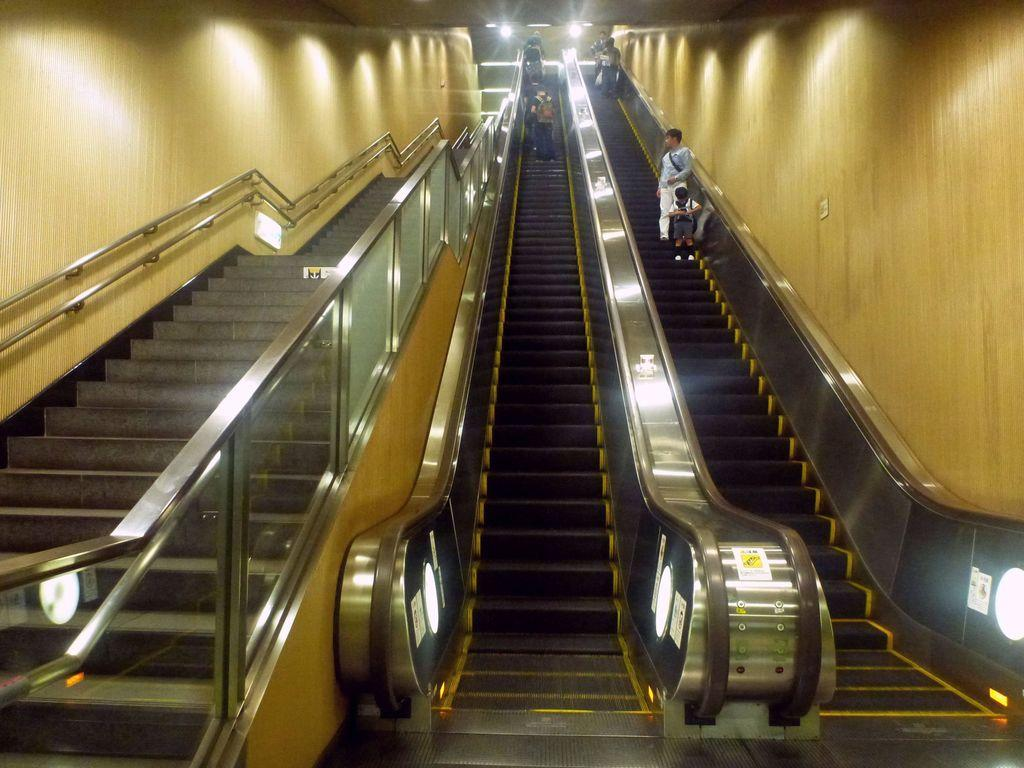Where was the image taken from? The image was taken from inside. What can be seen in the image? There is an escalator in the image, and people are on the escalator. What else is visible in the background of the image? There are lights visible in the background of the image. What type of action is the farm performing in the image? There is no farm present in the image, so it cannot be performing any actions. 